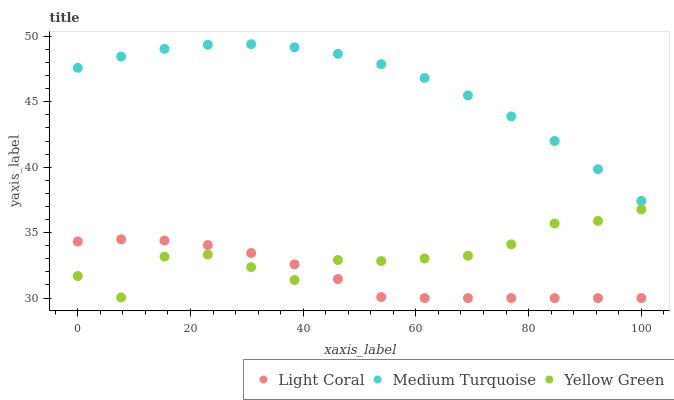Does Light Coral have the minimum area under the curve?
Answer yes or no. Yes. Does Medium Turquoise have the maximum area under the curve?
Answer yes or no. Yes. Does Yellow Green have the minimum area under the curve?
Answer yes or no. No. Does Yellow Green have the maximum area under the curve?
Answer yes or no. No. Is Light Coral the smoothest?
Answer yes or no. Yes. Is Yellow Green the roughest?
Answer yes or no. Yes. Is Medium Turquoise the smoothest?
Answer yes or no. No. Is Medium Turquoise the roughest?
Answer yes or no. No. Does Light Coral have the lowest value?
Answer yes or no. Yes. Does Yellow Green have the lowest value?
Answer yes or no. No. Does Medium Turquoise have the highest value?
Answer yes or no. Yes. Does Yellow Green have the highest value?
Answer yes or no. No. Is Light Coral less than Medium Turquoise?
Answer yes or no. Yes. Is Medium Turquoise greater than Light Coral?
Answer yes or no. Yes. Does Light Coral intersect Yellow Green?
Answer yes or no. Yes. Is Light Coral less than Yellow Green?
Answer yes or no. No. Is Light Coral greater than Yellow Green?
Answer yes or no. No. Does Light Coral intersect Medium Turquoise?
Answer yes or no. No. 